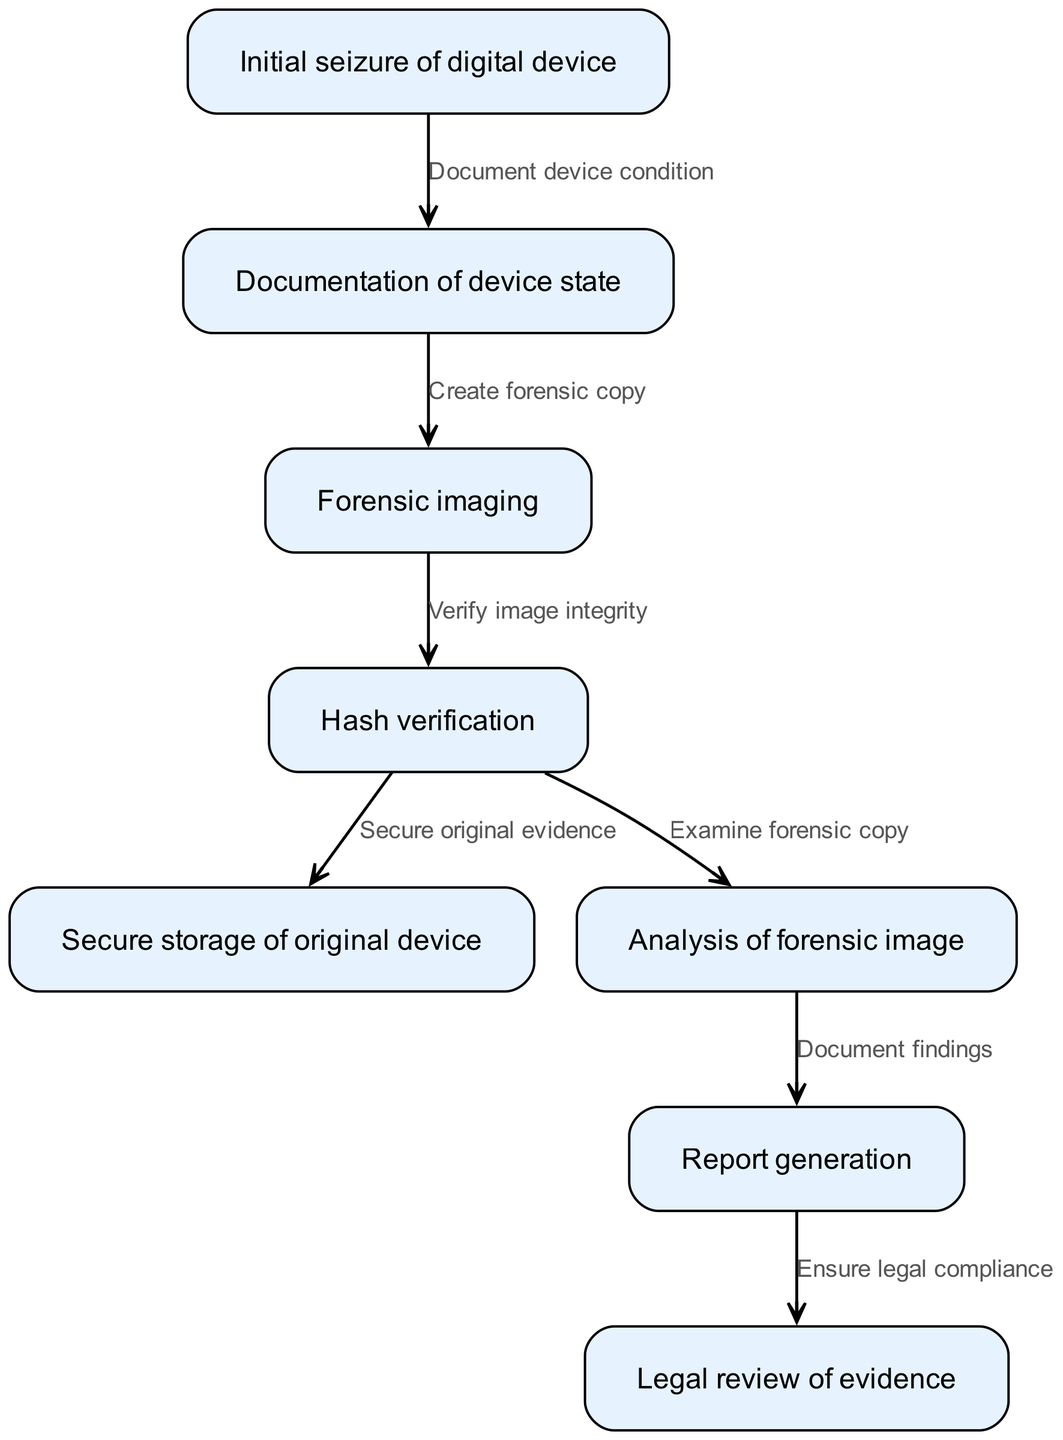What is the first step in the chain of custody process? The diagram indicates that the first step is "Initial seizure of digital device." This is represented as the first node in the diagram, showing the starting point of the chain of custody process.
Answer: Initial seizure of digital device How many edges are there in the diagram? By counting the connections between the nodes, there are a total of 7 edges connecting different steps in the chain of custody process. Each edge represents a transition from one step to the next.
Answer: 7 What is the relationship between "Hash verification" and "Secure storage of original device"? The diagram shows that "Hash verification" leads to two other nodes: "Secure original evidence" and "Examine forensic copy." This indicates that after verifying the hash integrity, the original evidence can be secured.
Answer: Secure original evidence Which step comes after "Analysis of forensic image"? According to the flow in the diagram, "Report generation" follows the step of "Analysis of forensic image." This means that after analyzing the forensic image, findings are documented in a report.
Answer: Report generation What step ensures legal compliance? The last part of the process is "Legal review of evidence." This step clarifies that it is specifically focused on ensuring that the evidence aligns with legal protocols and standards.
Answer: Legal review of evidence How are the processes of "Forensic imaging" and "Hash verification" connected? The edge from "Forensic imaging" to "Hash verification" in the diagram shows that after creating a forensic copy of the device, the next step is to verify the integrity of that image using a hash check, ensuring it is an accurate representation.
Answer: Verify image integrity What must happen before the "Secure storage of original device"? The diagram specifies that "Hash verification" must occur before "Secure storage of original device," indicating that the integrity of the evidence must be confirmed before securely storing it.
Answer: Hash verification 